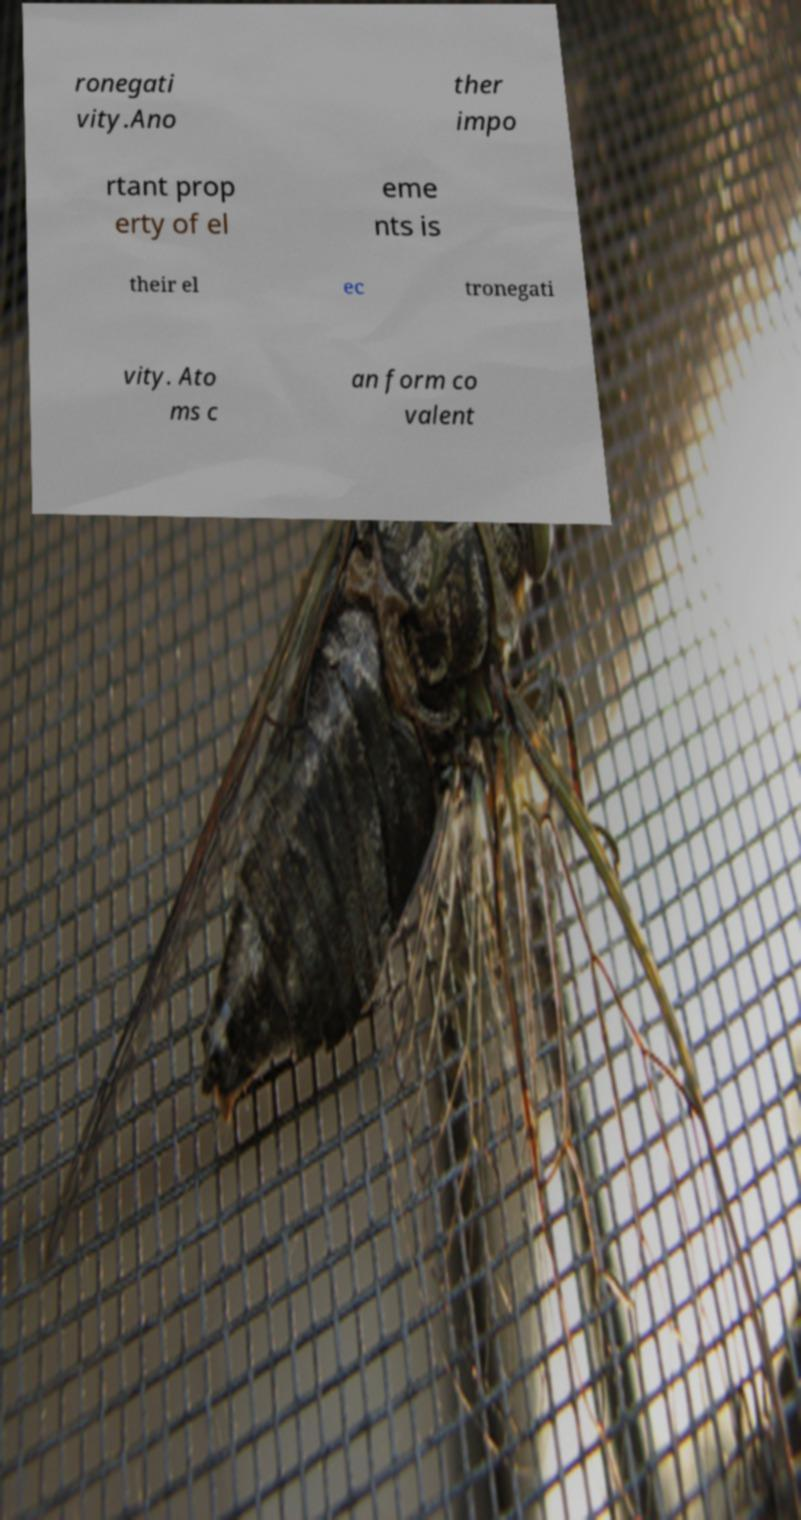I need the written content from this picture converted into text. Can you do that? ronegati vity.Ano ther impo rtant prop erty of el eme nts is their el ec tronegati vity. Ato ms c an form co valent 